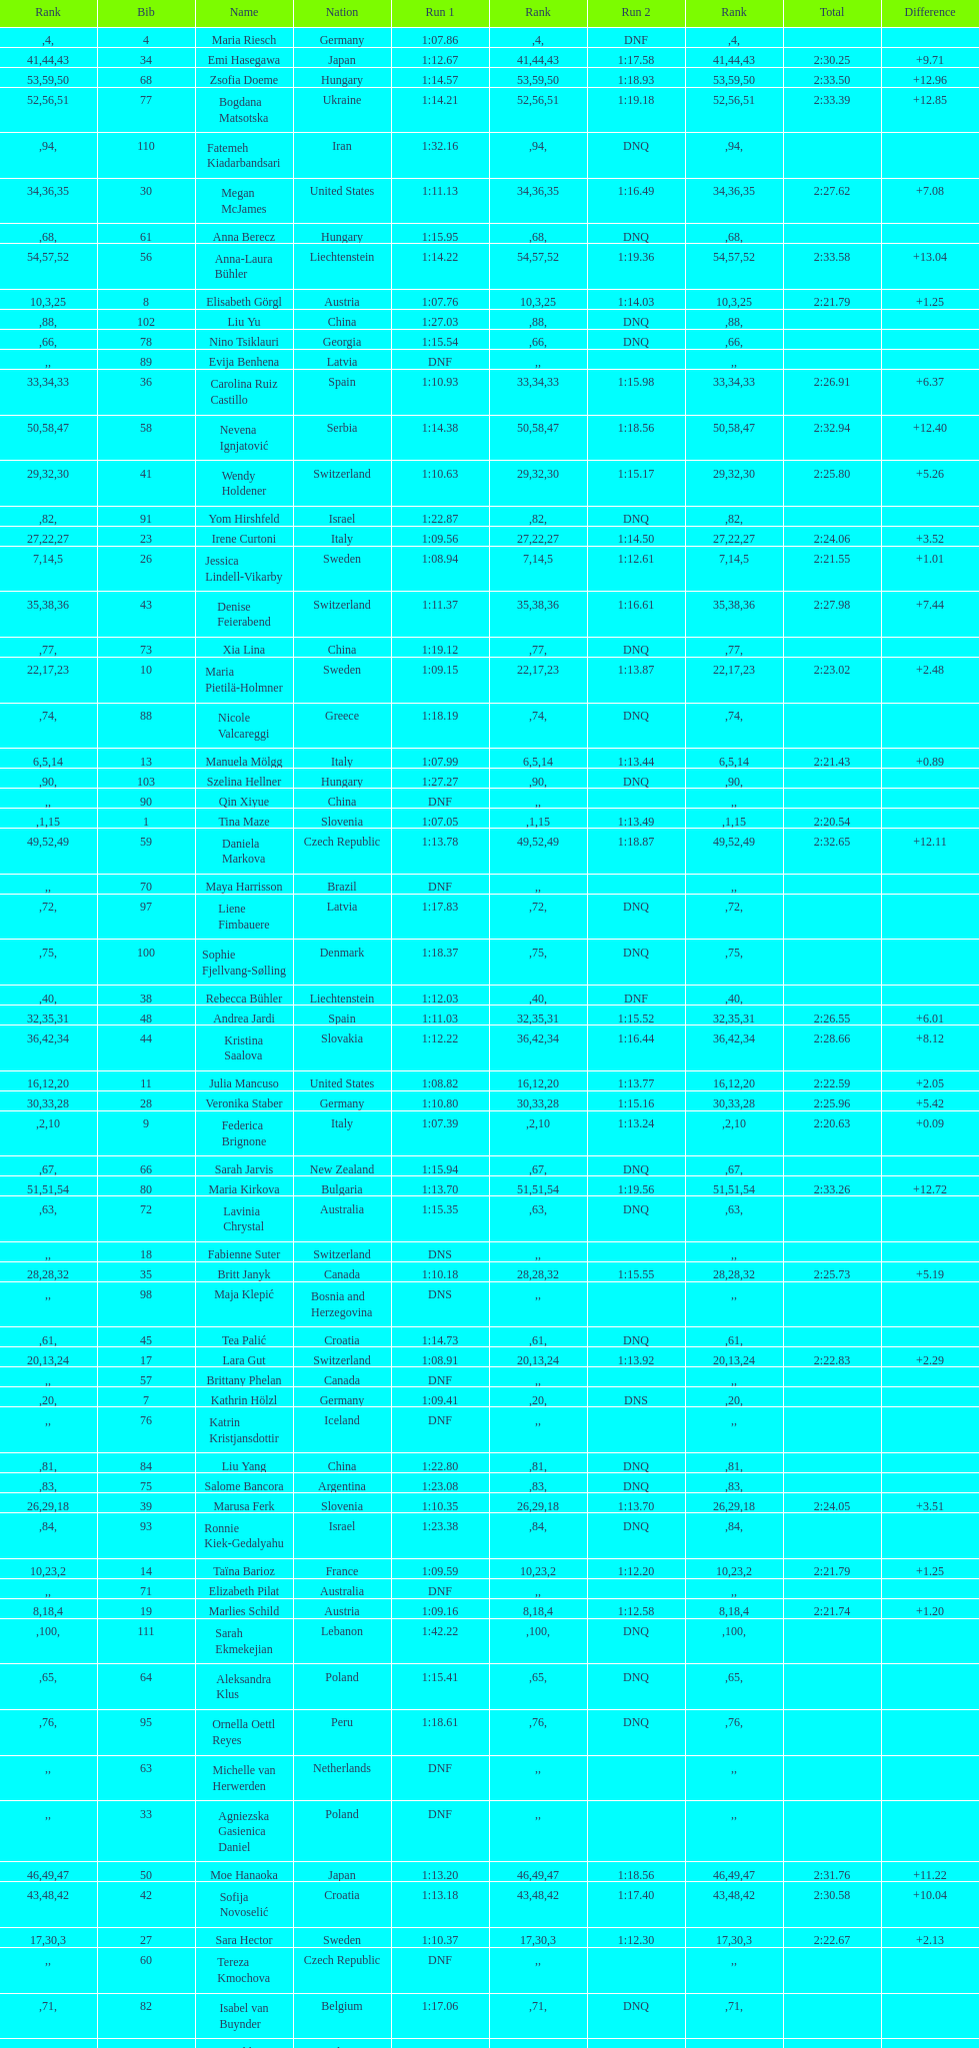How many total names are there? 116. 